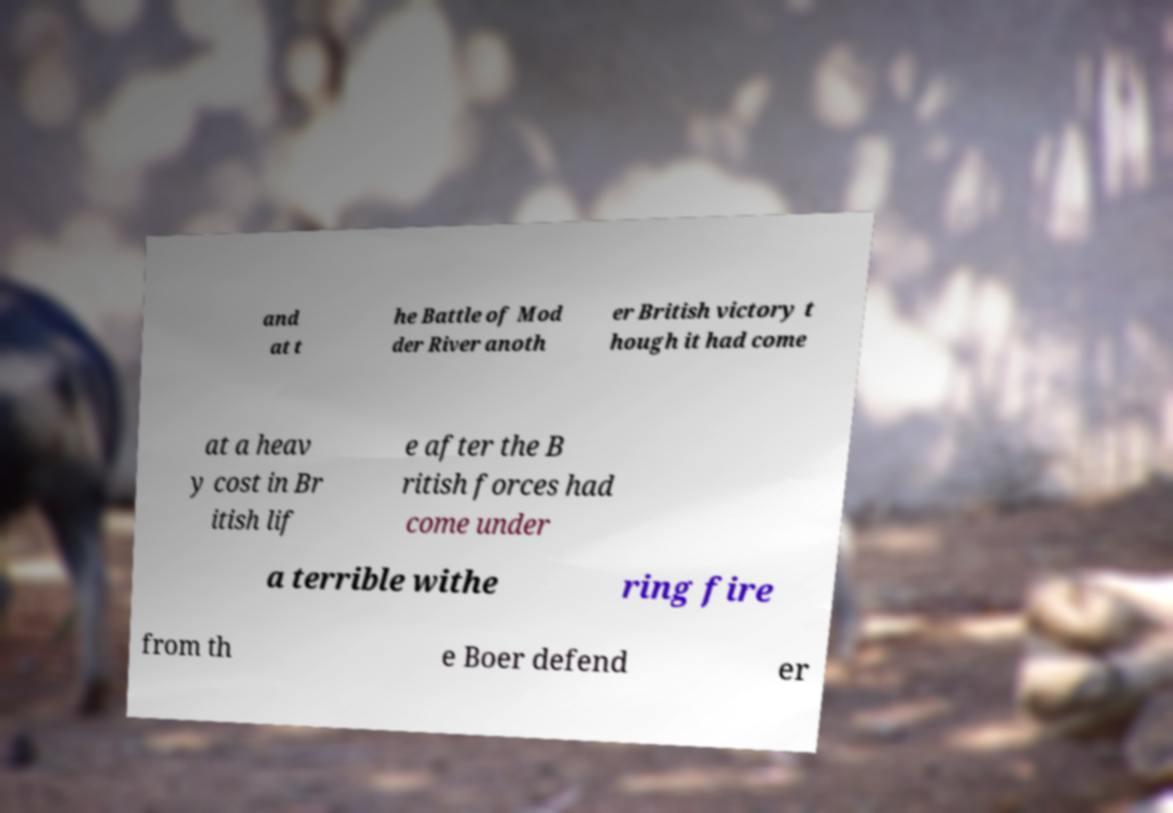There's text embedded in this image that I need extracted. Can you transcribe it verbatim? and at t he Battle of Mod der River anoth er British victory t hough it had come at a heav y cost in Br itish lif e after the B ritish forces had come under a terrible withe ring fire from th e Boer defend er 